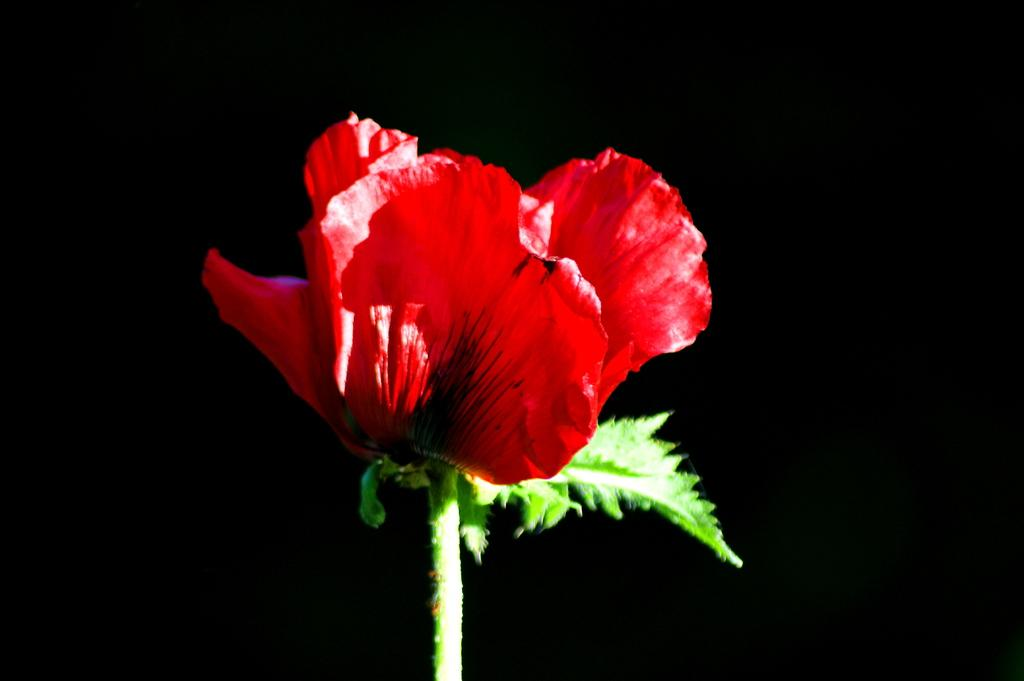What is the main subject in the foreground of the image? There is a flower in the foreground of the image. What color is the background of the image? The background of the image is black. Where is the key located in the image? There is no key present in the image. How long does it take for the beam to pass through the image? There is no beam present in the image, so it cannot be determined how long it would take for it to pass through. 